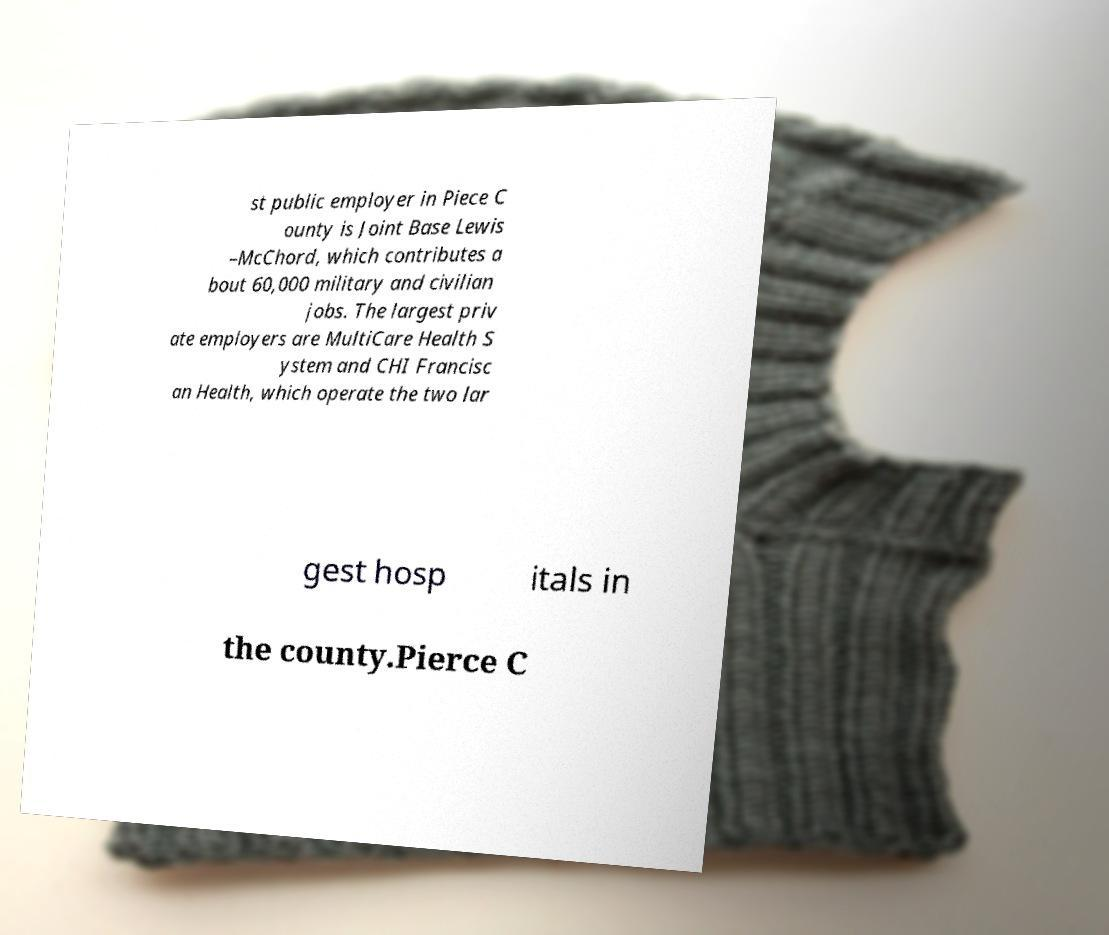Can you read and provide the text displayed in the image?This photo seems to have some interesting text. Can you extract and type it out for me? st public employer in Piece C ounty is Joint Base Lewis –McChord, which contributes a bout 60,000 military and civilian jobs. The largest priv ate employers are MultiCare Health S ystem and CHI Francisc an Health, which operate the two lar gest hosp itals in the county.Pierce C 